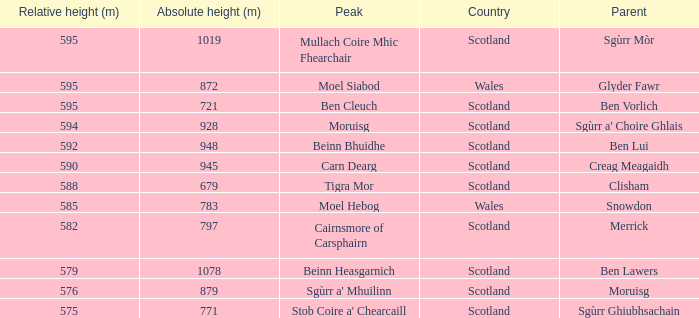What is the relative height of Scotland with Ben Vorlich as parent? 1.0. 